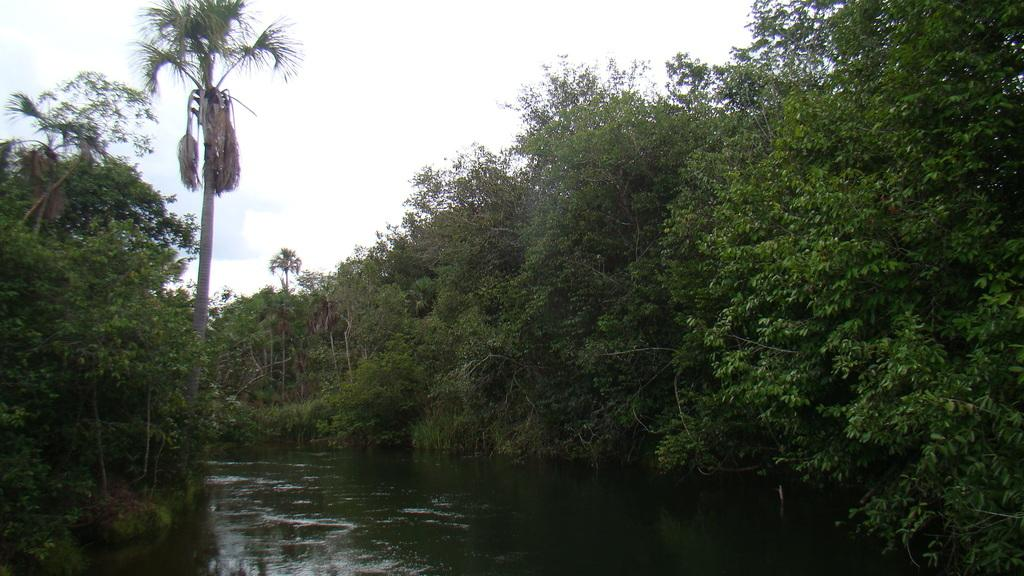What type of vegetation can be seen in the image? There are many trees in the image. What is visible at the top of the image? The sky is visible at the top of the image. What natural element is present at the bottom of the image? Water is present at the bottom of the image. How many brothers are depicted in the image? There are no brothers depicted in the image; it only features trees, sky, and water. What type of trouble can be seen in the image? There is no trouble depicted in the image; it is a natural scene with trees, sky, and water. 